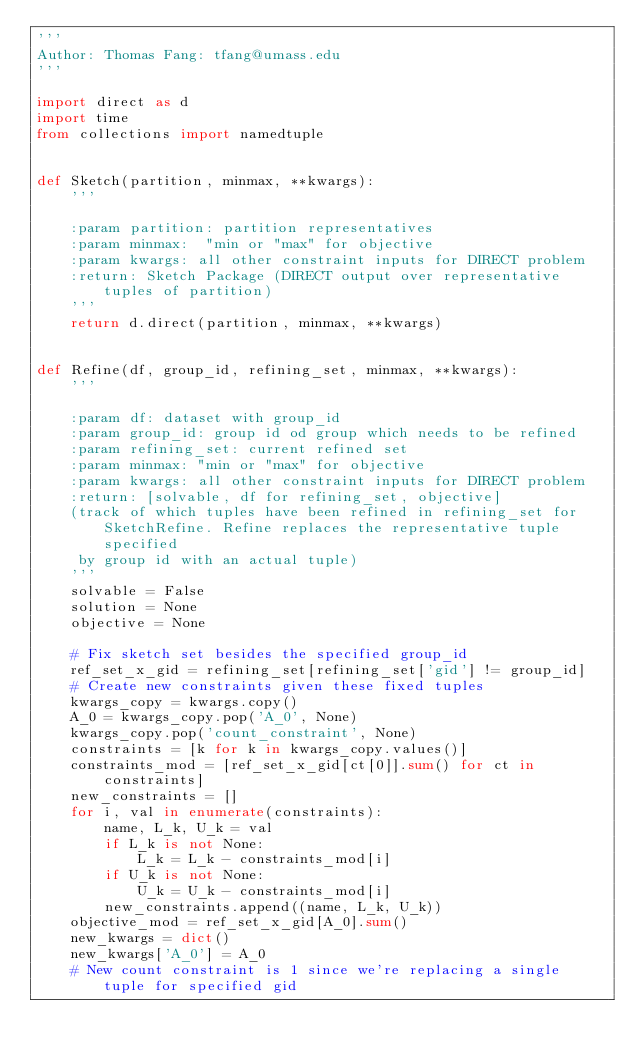<code> <loc_0><loc_0><loc_500><loc_500><_Python_>'''
Author: Thomas Fang: tfang@umass.edu
'''

import direct as d
import time
from collections import namedtuple


def Sketch(partition, minmax, **kwargs):
    '''

    :param partition: partition representatives
    :param minmax:  "min or "max" for objective
    :param kwargs: all other constraint inputs for DIRECT problem
    :return: Sketch Package (DIRECT output over representative tuples of partition)
    '''
    return d.direct(partition, minmax, **kwargs)


def Refine(df, group_id, refining_set, minmax, **kwargs):
    '''

    :param df: dataset with group_id
    :param group_id: group id od group which needs to be refined
    :param refining_set: current refined set
    :param minmax: "min or "max" for objective
    :param kwargs: all other constraint inputs for DIRECT problem
    :return: [solvable, df for refining_set, objective]
    (track of which tuples have been refined in refining_set for SketchRefine. Refine replaces the representative tuple specified
     by group id with an actual tuple)
    '''
    solvable = False
    solution = None
    objective = None

    # Fix sketch set besides the specified group_id
    ref_set_x_gid = refining_set[refining_set['gid'] != group_id]
    # Create new constraints given these fixed tuples
    kwargs_copy = kwargs.copy()
    A_0 = kwargs_copy.pop('A_0', None)
    kwargs_copy.pop('count_constraint', None)
    constraints = [k for k in kwargs_copy.values()]
    constraints_mod = [ref_set_x_gid[ct[0]].sum() for ct in constraints]
    new_constraints = []
    for i, val in enumerate(constraints):
        name, L_k, U_k = val
        if L_k is not None:
            L_k = L_k - constraints_mod[i]
        if U_k is not None:
            U_k = U_k - constraints_mod[i]
        new_constraints.append((name, L_k, U_k))
    objective_mod = ref_set_x_gid[A_0].sum()
    new_kwargs = dict()
    new_kwargs['A_0'] = A_0
    # New count constraint is 1 since we're replacing a single tuple for specified gid</code> 